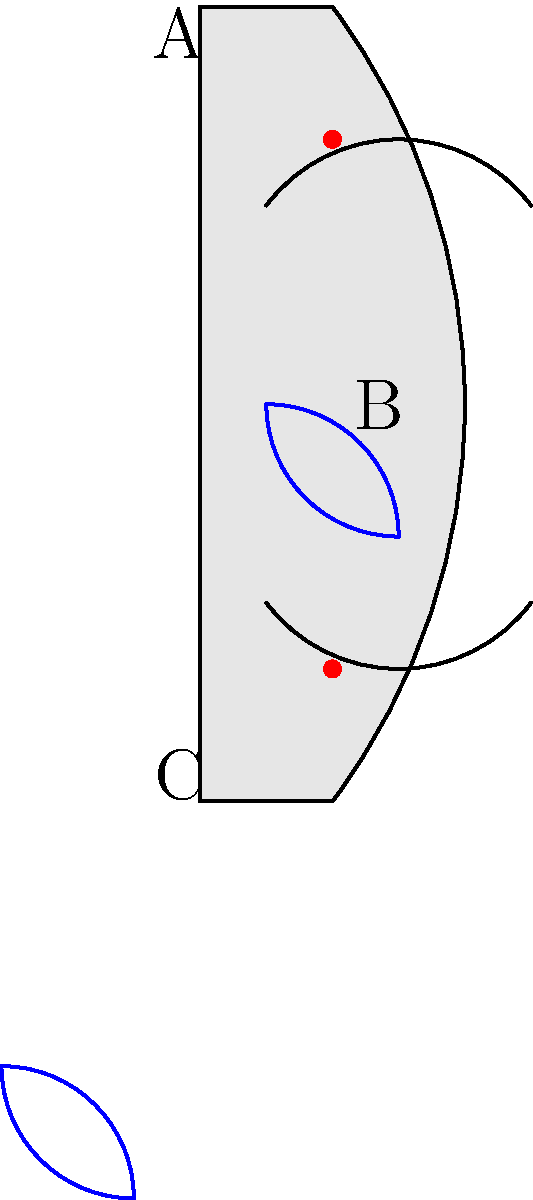Based on the design elements shown in the ancient artifact, which civilization is most likely to have produced this piece? Consider the spiral motifs, symmetrical handles, and the placement of decorative dots. To determine the origin of this ancient artifact, let's analyze its design elements step-by-step:

1. Overall shape: The artifact is a vase with a symmetrical design, featuring two handles (A and C) and a rounded body.

2. Spiral motifs (B): The prominent blue spiral patterns are a key identifying feature. These types of spirals are commonly associated with Minoan civilization, particularly in their pottery from the Bronze Age (c. 3000-1100 BCE).

3. Symmetrical handles: The presence of two symmetrical handles is consistent with Minoan pottery designs, often seen in their amphoras and other vessel types.

4. Decorative dots: The red dots placed at the top and bottom of the vase are another characteristic of Minoan artistic style, often used to add visual interest and balance to their designs.

5. Color scheme: Although limited in this representation, the use of blue for the spirals is reminiscent of the blue pigments often used in Minoan frescoes and pottery.

6. Proportions: The elongated shape with a narrow base widening towards the top is typical of Minoan vase forms, particularly those from the Middle to Late Minoan periods.

Given these design elements, particularly the distinctive spiral motifs and the overall composition, this artifact bears strong resemblance to Minoan pottery. The Minoan civilization, centered on the island of Crete, was known for its sophisticated pottery and artistic designs during the Bronze Age.
Answer: Minoan civilization 